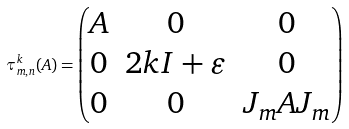Convert formula to latex. <formula><loc_0><loc_0><loc_500><loc_500>\tau _ { m , n } ^ { k } ( A ) = \begin{pmatrix} A & 0 & 0 \\ 0 & 2 k I + \varepsilon & 0 \\ 0 & 0 & J _ { m } A J _ { m } \end{pmatrix}</formula> 